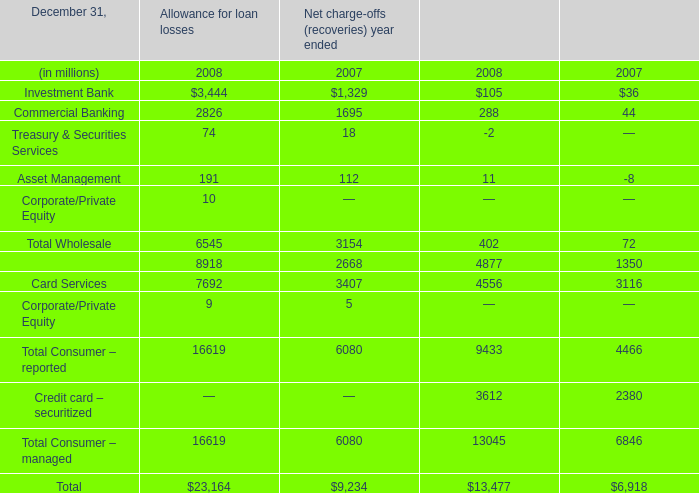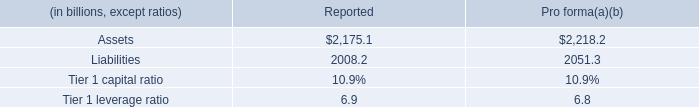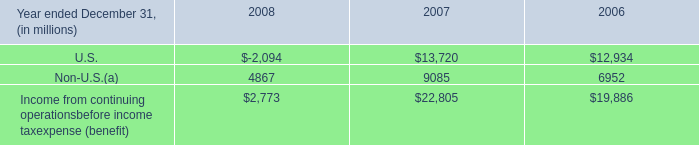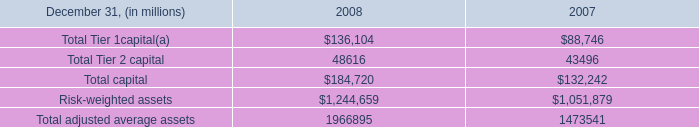what was the ratio of the total amount of expected loss notes out- standing at december 31 , 2008 compared to 2007 
Computations: (136 / 130)
Answer: 1.04615. 